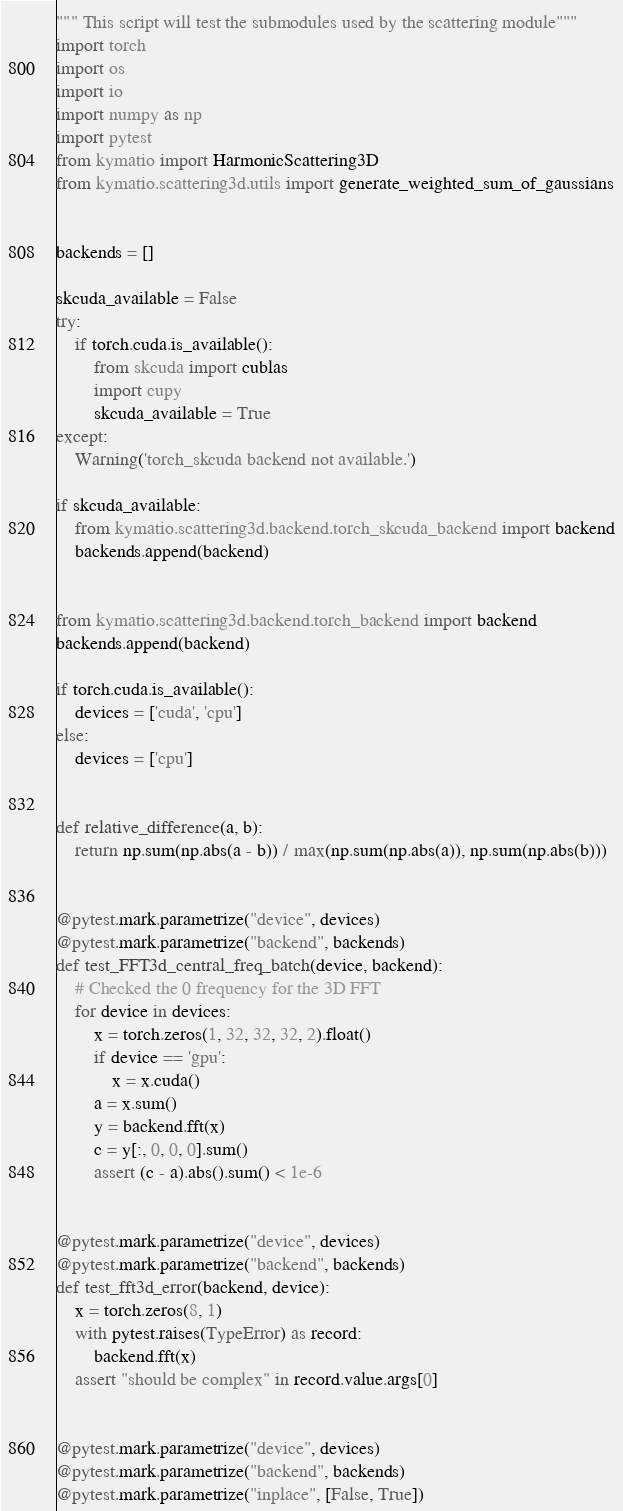<code> <loc_0><loc_0><loc_500><loc_500><_Python_>""" This script will test the submodules used by the scattering module"""
import torch
import os
import io
import numpy as np
import pytest
from kymatio import HarmonicScattering3D
from kymatio.scattering3d.utils import generate_weighted_sum_of_gaussians


backends = []

skcuda_available = False
try:
    if torch.cuda.is_available():
        from skcuda import cublas
        import cupy
        skcuda_available = True
except:
    Warning('torch_skcuda backend not available.')

if skcuda_available:
    from kymatio.scattering3d.backend.torch_skcuda_backend import backend
    backends.append(backend)


from kymatio.scattering3d.backend.torch_backend import backend
backends.append(backend)

if torch.cuda.is_available():
    devices = ['cuda', 'cpu']
else:
    devices = ['cpu']


def relative_difference(a, b):
    return np.sum(np.abs(a - b)) / max(np.sum(np.abs(a)), np.sum(np.abs(b)))


@pytest.mark.parametrize("device", devices)
@pytest.mark.parametrize("backend", backends)
def test_FFT3d_central_freq_batch(device, backend):
    # Checked the 0 frequency for the 3D FFT
    for device in devices:
        x = torch.zeros(1, 32, 32, 32, 2).float()
        if device == 'gpu':
            x = x.cuda()
        a = x.sum()
        y = backend.fft(x)
        c = y[:, 0, 0, 0].sum()
        assert (c - a).abs().sum() < 1e-6


@pytest.mark.parametrize("device", devices)
@pytest.mark.parametrize("backend", backends)
def test_fft3d_error(backend, device):
    x = torch.zeros(8, 1)
    with pytest.raises(TypeError) as record:
        backend.fft(x)
    assert "should be complex" in record.value.args[0]


@pytest.mark.parametrize("device", devices)
@pytest.mark.parametrize("backend", backends)
@pytest.mark.parametrize("inplace", [False, True])</code> 